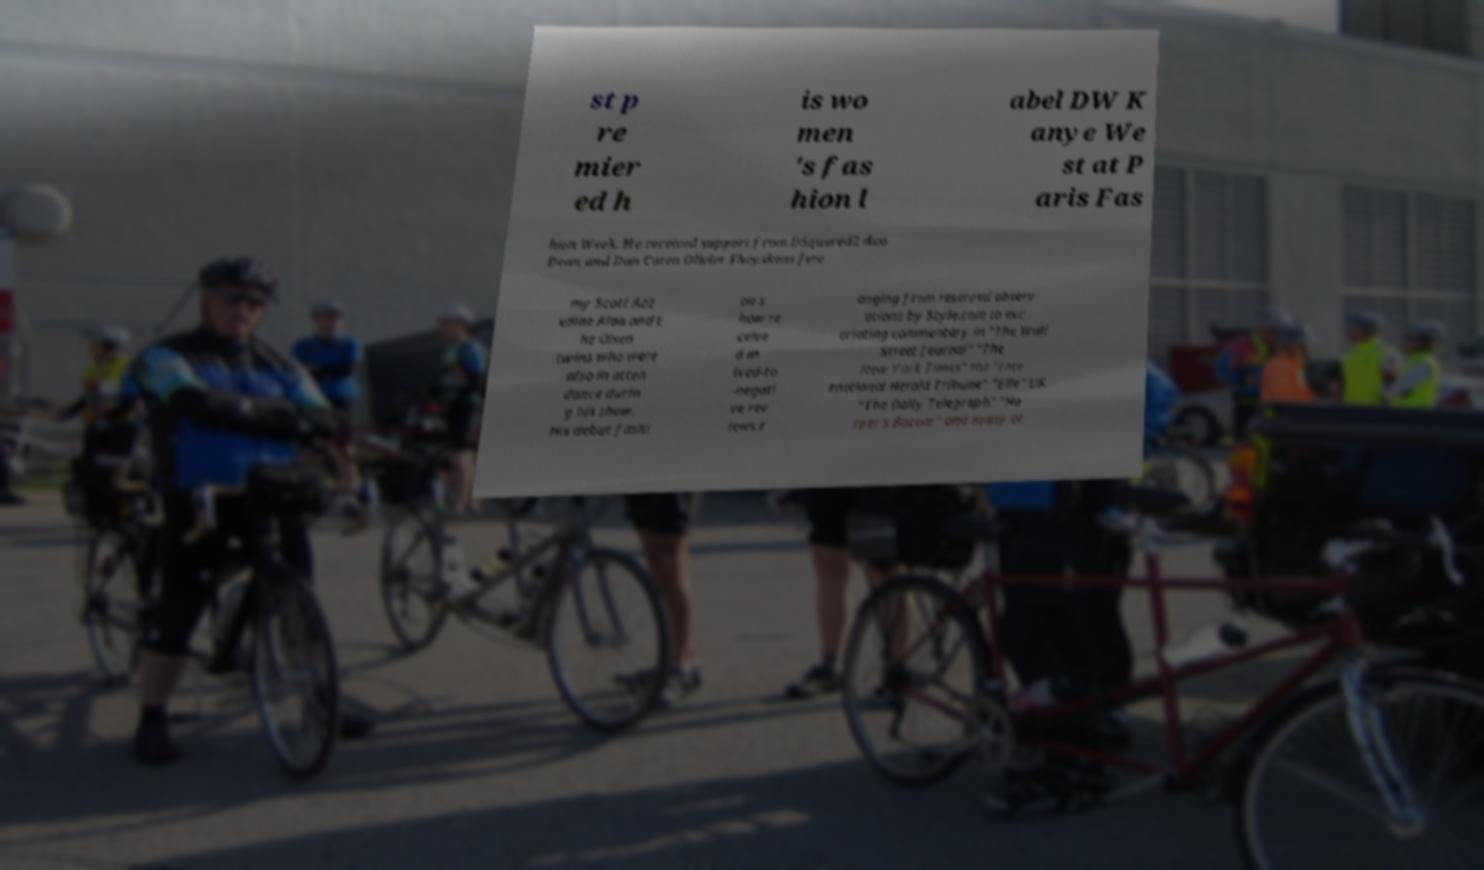I need the written content from this picture converted into text. Can you do that? st p re mier ed h is wo men 's fas hion l abel DW K anye We st at P aris Fas hion Week. He received support from DSquared2 duo Dean and Dan Caten Olivier Theyskens Jere my Scott Azz edine Alaa and t he Olsen twins who were also in atten dance durin g his show. His debut fashi on s how re ceive d m ixed-to -negati ve rev iews r anging from reserved observ ations by Style.com to exc oriating commentary in "The Wall Street Journal" "The New York Times" the "Inte rnational Herald Tribune" "Elle" UK "The Daily Telegraph" "Ha rper's Bazaar" and many ot 